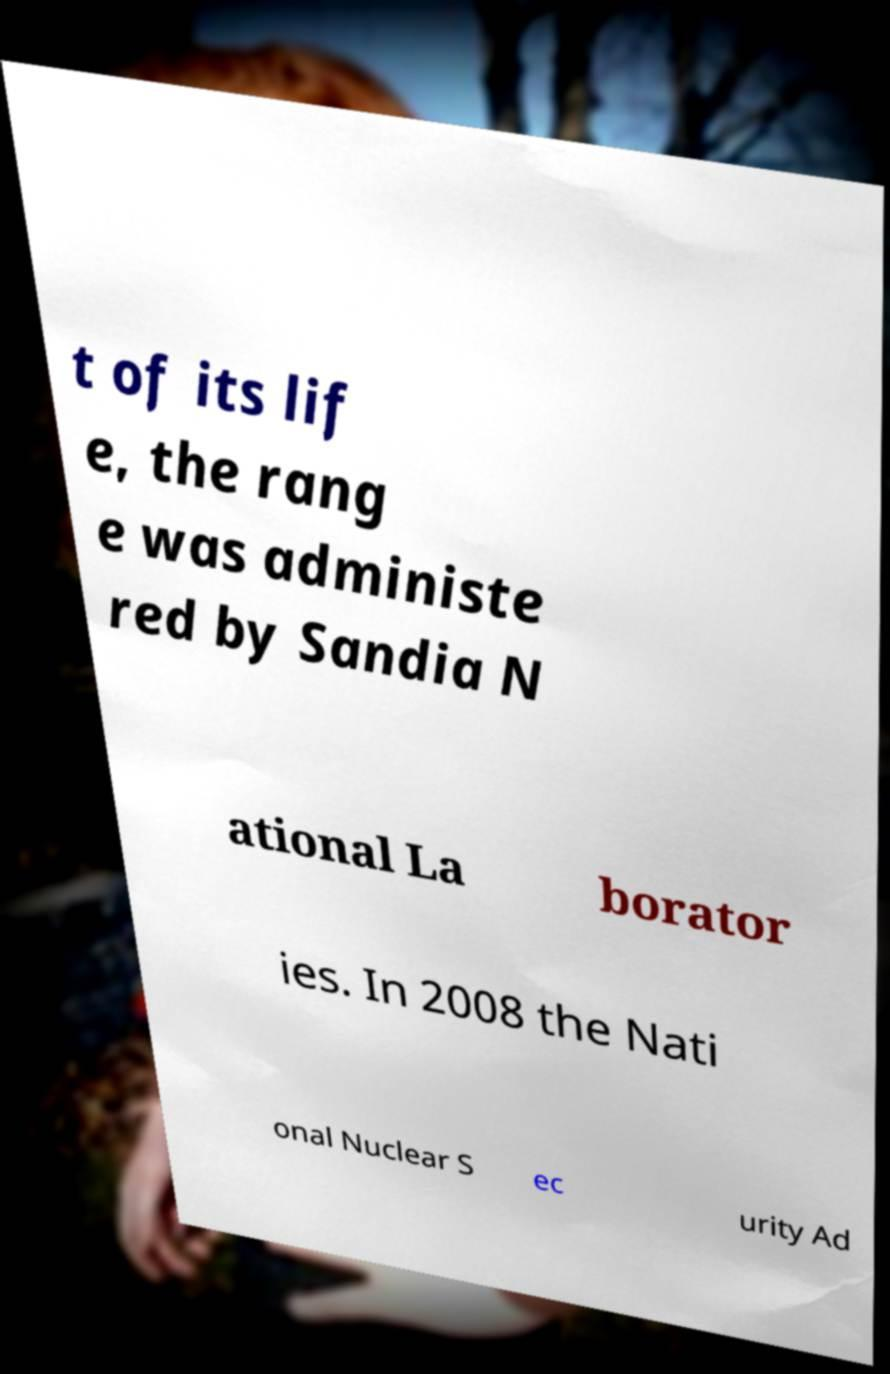For documentation purposes, I need the text within this image transcribed. Could you provide that? t of its lif e, the rang e was administe red by Sandia N ational La borator ies. In 2008 the Nati onal Nuclear S ec urity Ad 